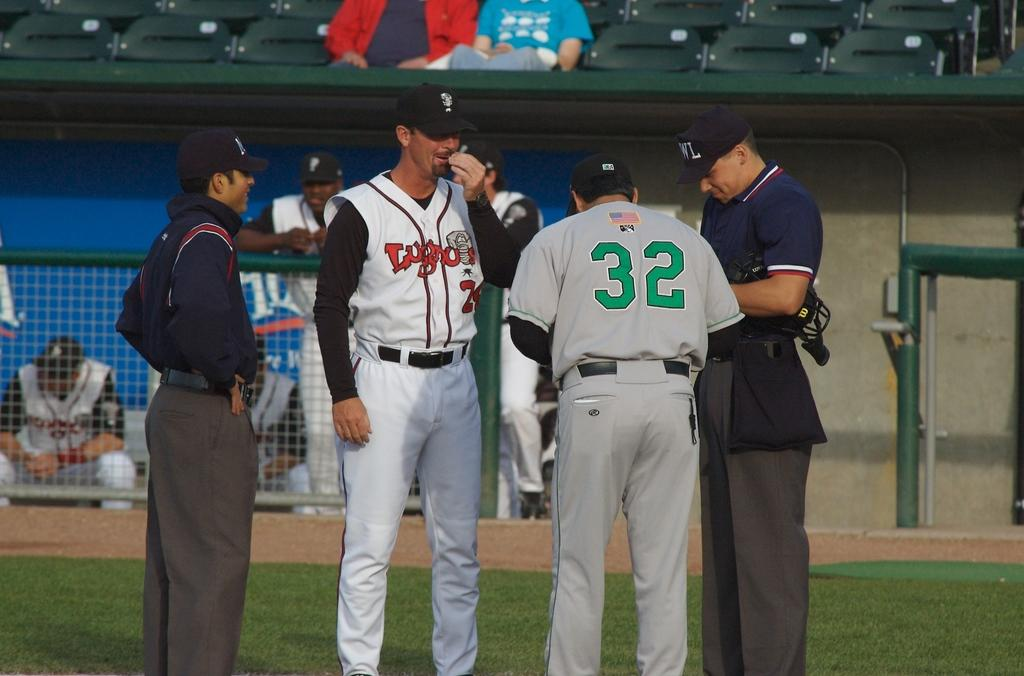Provide a one-sentence caption for the provided image. Player number 32 consults with the umpires on the field. 